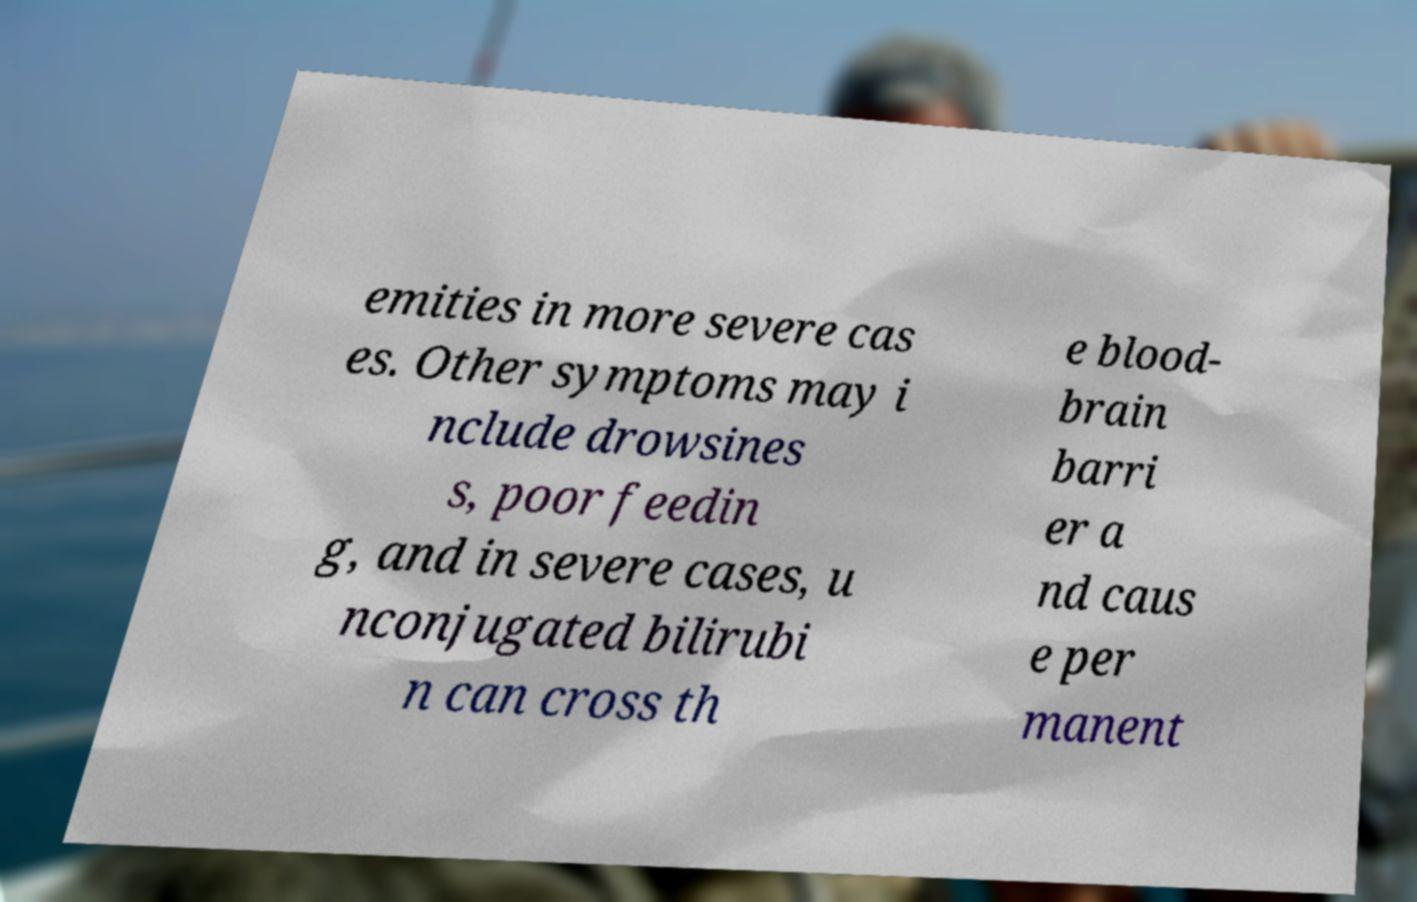I need the written content from this picture converted into text. Can you do that? emities in more severe cas es. Other symptoms may i nclude drowsines s, poor feedin g, and in severe cases, u nconjugated bilirubi n can cross th e blood- brain barri er a nd caus e per manent 